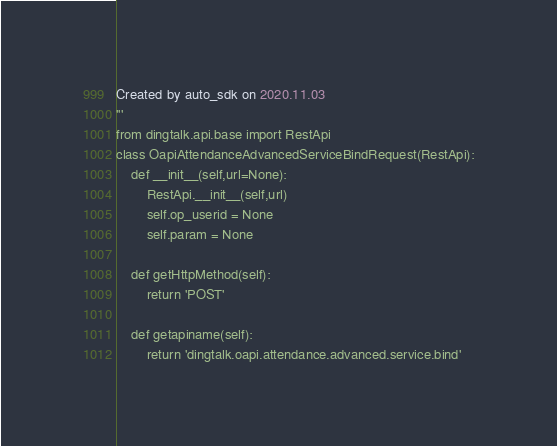<code> <loc_0><loc_0><loc_500><loc_500><_Python_>Created by auto_sdk on 2020.11.03
'''
from dingtalk.api.base import RestApi
class OapiAttendanceAdvancedServiceBindRequest(RestApi):
	def __init__(self,url=None):
		RestApi.__init__(self,url)
		self.op_userid = None
		self.param = None

	def getHttpMethod(self):
		return 'POST'

	def getapiname(self):
		return 'dingtalk.oapi.attendance.advanced.service.bind'
</code> 